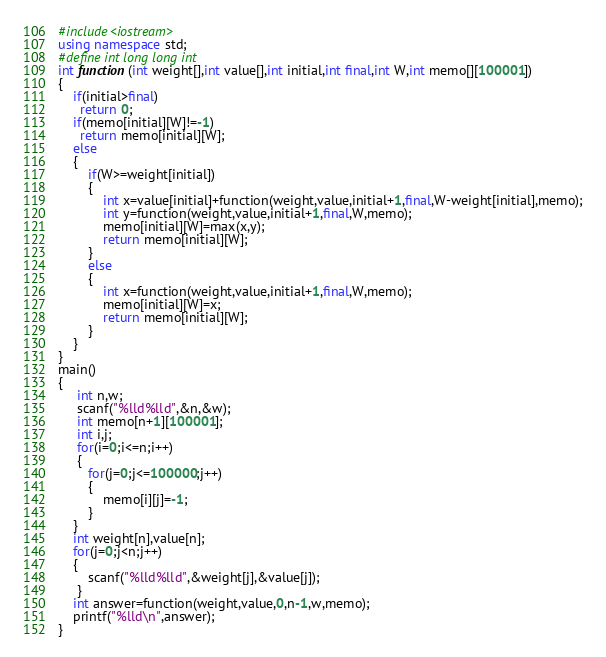<code> <loc_0><loc_0><loc_500><loc_500><_C++_>#include<iostream>
using namespace std;
#define int long long int
int function(int weight[],int value[],int initial,int final,int W,int memo[][100001])
{
	if(initial>final)
	  return 0;
	if(memo[initial][W]!=-1)
	  return memo[initial][W];
	else
	{
		if(W>=weight[initial])
		{
			int x=value[initial]+function(weight,value,initial+1,final,W-weight[initial],memo);
			int y=function(weight,value,initial+1,final,W,memo);
			memo[initial][W]=max(x,y);
			return memo[initial][W];
		}
		else
		{
			int x=function(weight,value,initial+1,final,W,memo);
			memo[initial][W]=x;
			return memo[initial][W];
		}
	}
}
main()
{
     int n,w;
	 scanf("%lld%lld",&n,&w);
	 int memo[n+1][100001];
	 int i,j;
	 for(i=0;i<=n;i++)
	 {
	 	for(j=0;j<=100000;j++)
	 	{
	 		memo[i][j]=-1;
		}
	}
	int weight[n],value[n];
	for(j=0;j<n;j++)
	{
		scanf("%lld%lld",&weight[j],&value[j]);
	 } 
	int answer=function(weight,value,0,n-1,w,memo);
	printf("%lld\n",answer);
}</code> 